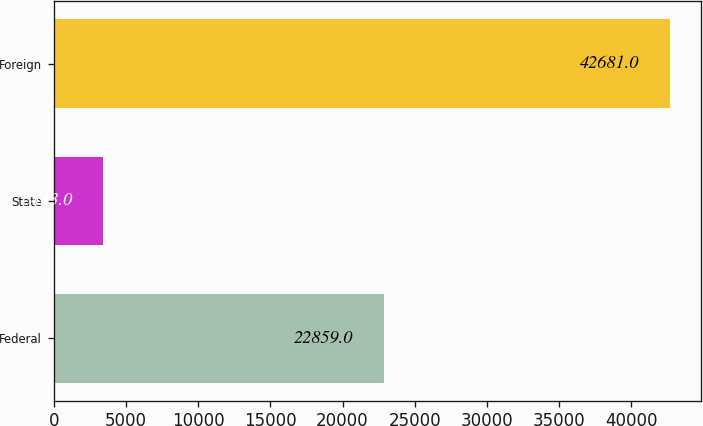Convert chart. <chart><loc_0><loc_0><loc_500><loc_500><bar_chart><fcel>Federal<fcel>State<fcel>Foreign<nl><fcel>22859<fcel>3443<fcel>42681<nl></chart> 